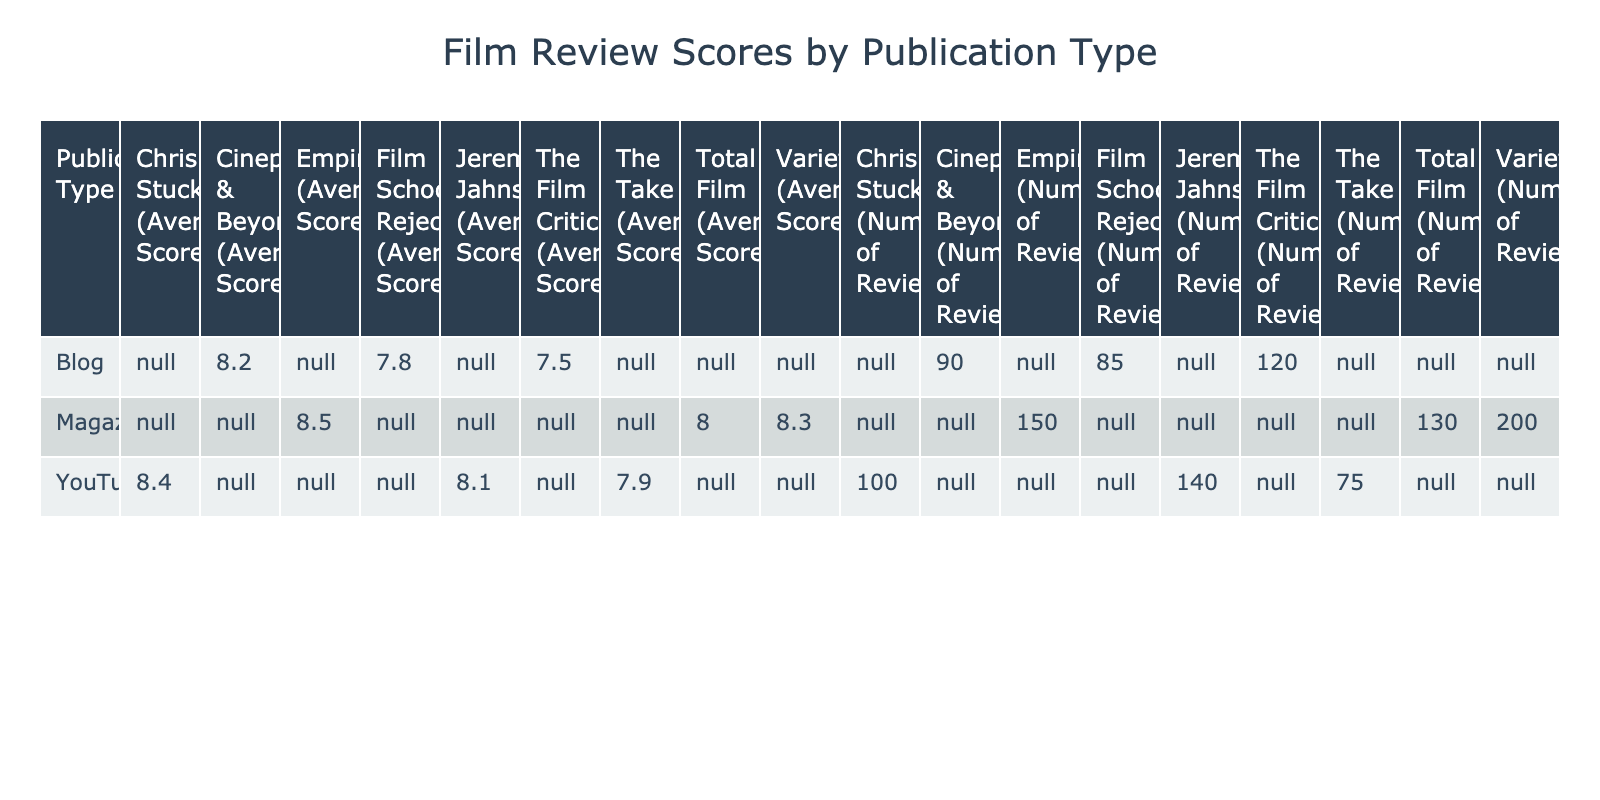What is the average score of 'Chris Stuckmann'? Looking at the row for 'Chris Stuckmann' under the 'YouTube' publication type, the table shows an average score of 8.4.
Answer: 8.4 Which publication has the highest average score? The table lists 'Empire' as having the highest average score of 8.5.
Answer: 8.5 How many reviews did 'Cinephilia & Beyond' have? Referring to the row for 'Cinephilia & Beyond' under the 'Blog' publication type, the table shows 90 reviews.
Answer: 90 What is the total number of reviews for all YouTube publications combined? Summing the number of reviews for YouTube publications: 100 (Chris Stuckmann) + 140 (Jeremy Jahns) + 75 (The Take) = 315.
Answer: 315 Is the average score of 'Variety' greater than 8.0? The table indicates that 'Variety' has an average score of 8.3, which is indeed greater than 8.0.
Answer: Yes What is the difference in average scores between 'Empire' and 'Film School Rejects'? The average score for 'Empire' is 8.5 and for 'Film School Rejects' is 7.8. The difference is calculated as 8.5 - 7.8 = 0.7.
Answer: 0.7 Which publication type has the most reviews in total? We summarize each publication type: Blogs (120 + 90 + 85 = 295), Magazines (150 + 130 + 200 = 480), and YouTube (100 + 140 + 75 = 315). Magazines have the most total reviews at 480.
Answer: Magazines Do any blogs have an average score of 8.0 or higher? Checking the average scores for blogs: The Film Critic (7.5), Cinephilia & Beyond (8.2), Film School Rejects (7.8). Only 'Cinephilia & Beyond' has an average score of 8.0 or higher.
Answer: Yes What is the average score of Magazine publications? Adding the average scores of the magazines: (8.5 + 8.0 + 8.3) = 24.8. Dividing by 3 gives an average score of 24.8 / 3 = 8.27.
Answer: 8.27 